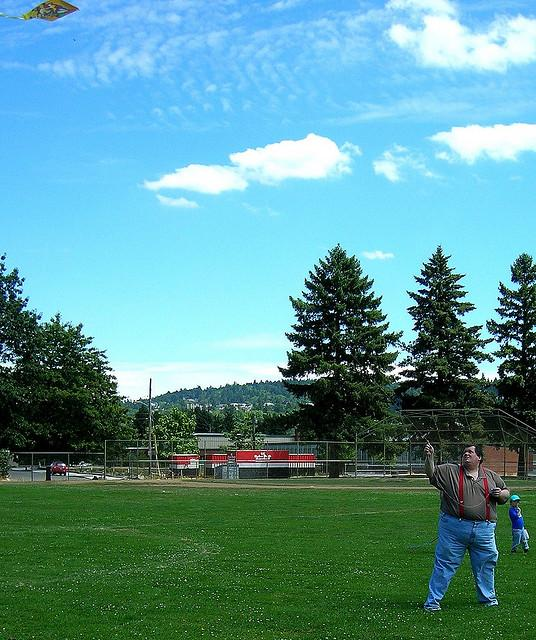The man in brown Controls what? Please explain your reasoning. kite. He is looking up at the kite and you can see a string in his hand. 